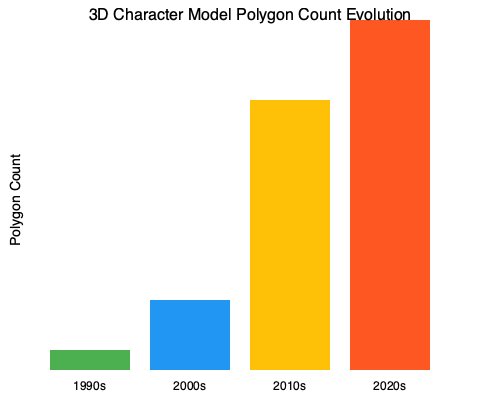Based on the graph showing the evolution of 3D character model polygon counts across gaming eras, approximately how many times did the polygon count increase from the 1990s to the 2000s? To determine the increase in polygon count from the 1990s to the 2000s, we need to follow these steps:

1. Identify the polygon count for the 1990s: The graph shows 500 polygons for this era.
2. Identify the polygon count for the 2000s: The graph shows 5K (5,000) polygons for this era.
3. Calculate the increase factor:
   $\text{Increase factor} = \frac{\text{2000s polygon count}}{\text{1990s polygon count}}$
   $= \frac{5,000}{500} = 10$

Therefore, the polygon count increased by a factor of 10 from the 1990s to the 2000s.

This significant increase reflects the rapid advancement in 3D graphics technology and processing power during this period, allowing for more detailed and complex character models in games like Doom 3 (2004) compared to the original Doom (1993).
Answer: 10 times 